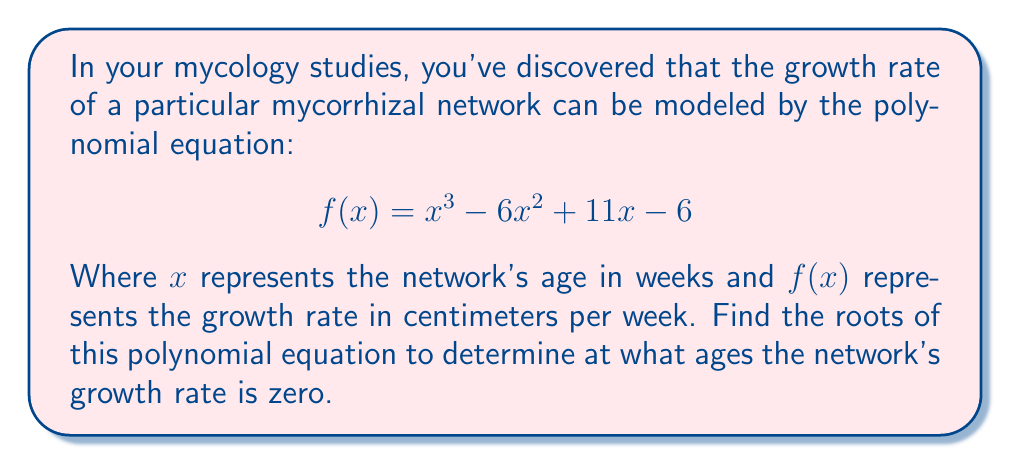What is the answer to this math problem? To find the roots of this polynomial equation, we need to factor the polynomial and solve for $x$ when $f(x) = 0$. Let's approach this step-by-step:

1) First, let's check if there are any rational roots using the rational root theorem. The possible rational roots are the factors of the constant term (6): ±1, ±2, ±3, ±6.

2) Testing these values, we find that $f(1) = 0$. So, $(x-1)$ is a factor.

3) We can use polynomial long division to divide $f(x)$ by $(x-1)$:

   $$\frac{x^3 - 6x^2 + 11x - 6}{x-1} = x^2 - 5x + 6$$

4) So, $f(x) = (x-1)(x^2 - 5x + 6)$

5) Now we need to factor $x^2 - 5x + 6$. This is a quadratic equation, and we can factor it as:

   $x^2 - 5x + 6 = (x-2)(x-3)$

6) Therefore, the fully factored polynomial is:

   $$f(x) = (x-1)(x-2)(x-3)$$

7) The roots of the polynomial are the values of $x$ that make each factor equal to zero. So, the roots are $x = 1$, $x = 2$, and $x = 3$.

These roots represent the ages (in weeks) at which the mycorrhizal network's growth rate is zero.
Answer: The roots of the polynomial equation are $x = 1$, $x = 2$, and $x = 3$. 